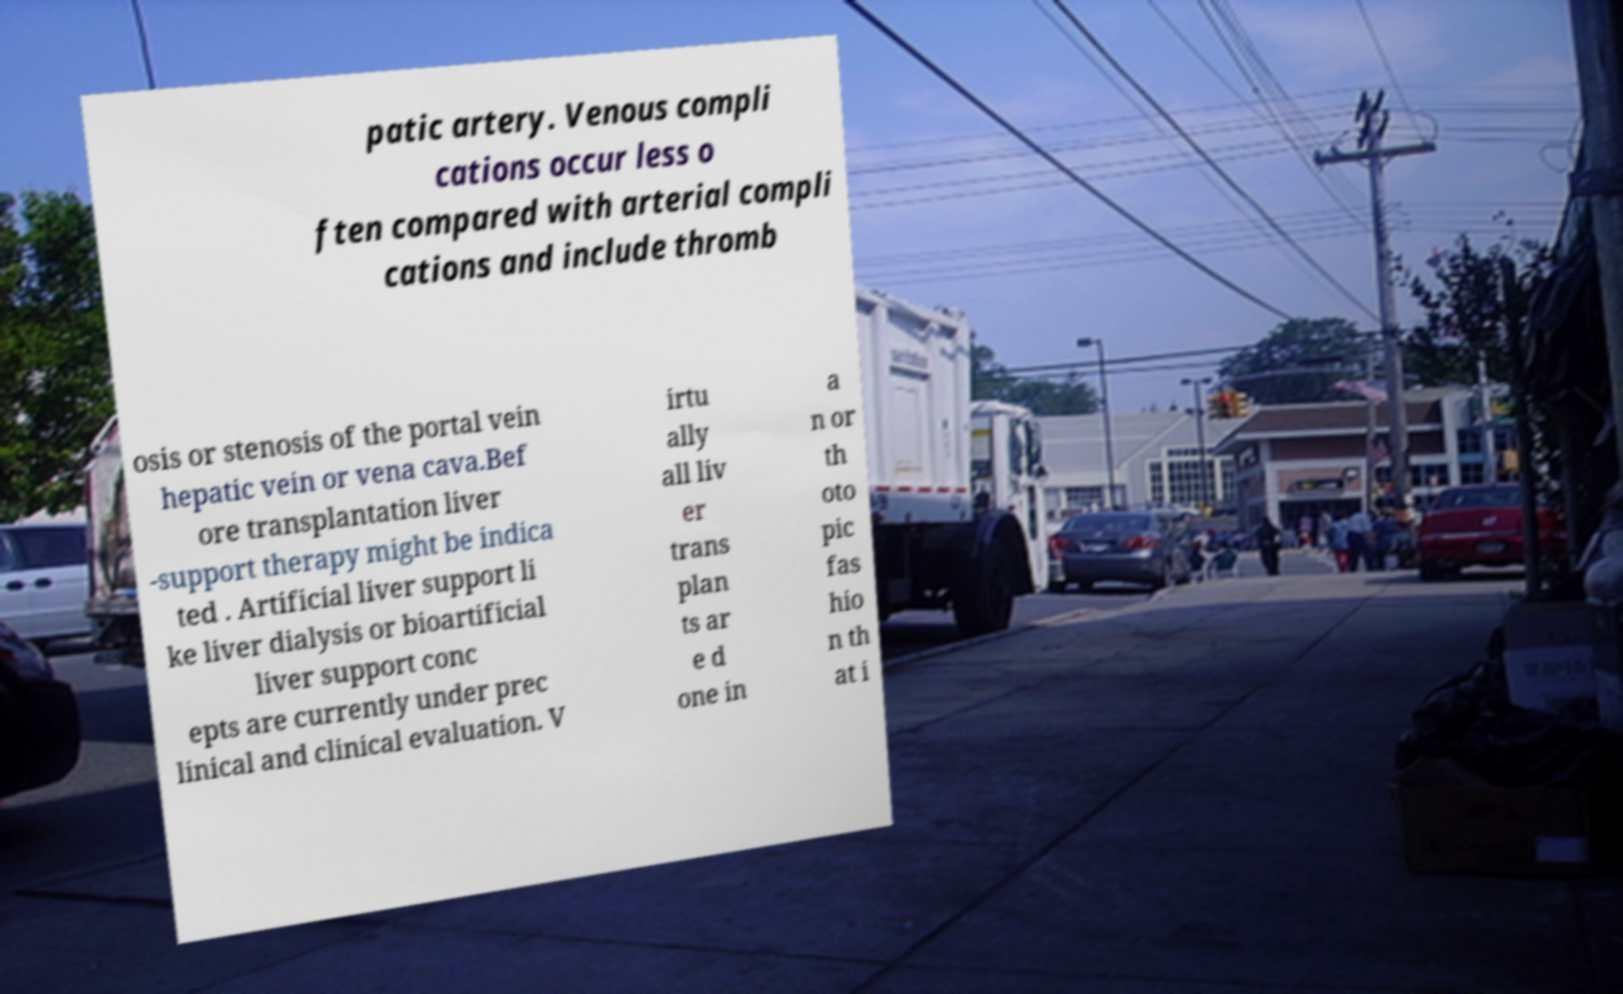For documentation purposes, I need the text within this image transcribed. Could you provide that? patic artery. Venous compli cations occur less o ften compared with arterial compli cations and include thromb osis or stenosis of the portal vein hepatic vein or vena cava.Bef ore transplantation liver -support therapy might be indica ted . Artificial liver support li ke liver dialysis or bioartificial liver support conc epts are currently under prec linical and clinical evaluation. V irtu ally all liv er trans plan ts ar e d one in a n or th oto pic fas hio n th at i 